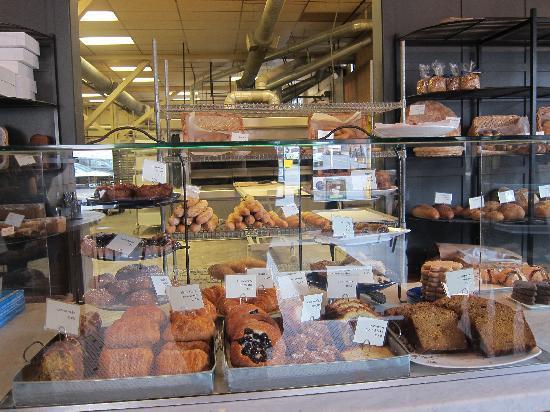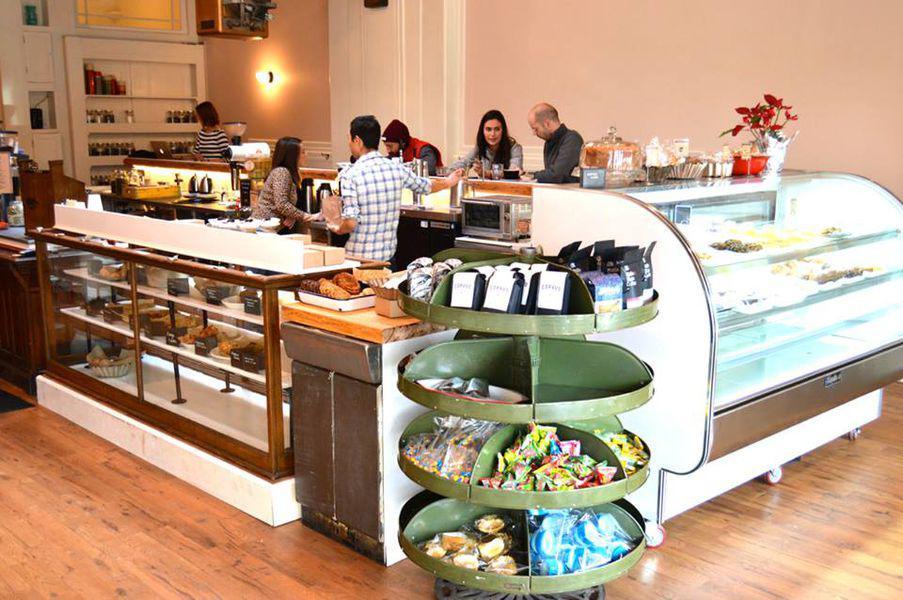The first image is the image on the left, the second image is the image on the right. Analyze the images presented: Is the assertion "In the image to the right, you can see the customers." valid? Answer yes or no. Yes. The first image is the image on the left, the second image is the image on the right. For the images shown, is this caption "An image shows two people standing upright a distance apart in front of a counter with a light wood front and a top filled with containers of baked treats marked with cards." true? Answer yes or no. No. 